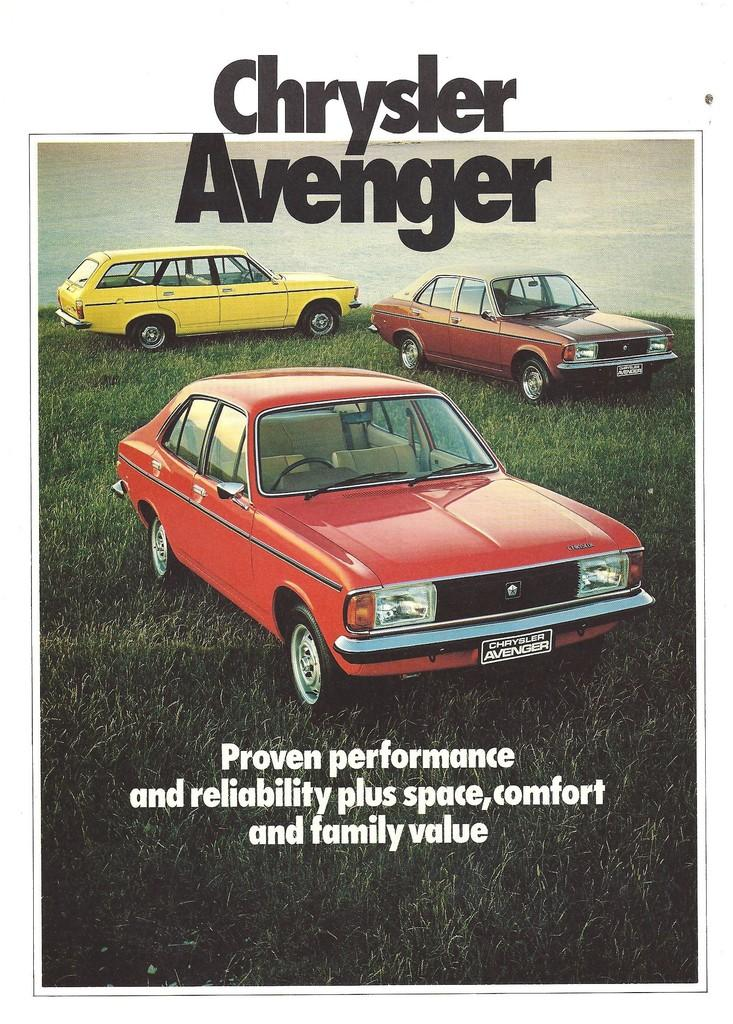What type of vehicles can be seen in the image? There are cars in the image. What type of vegetation is present in the image? There is grass in the image. Is there any text visible in the image? Yes, there is some text at the bottom of the image. What idea does the scene in the image represent? The image does not represent an idea; it is a visual representation of cars, grass, and text. How many bites can be seen being taken out of the grass in the image? There are no bites taken out of the grass in the image; it is a continuous expanse of vegetation. 